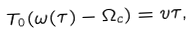Convert formula to latex. <formula><loc_0><loc_0><loc_500><loc_500>T _ { 0 } ( \omega ( \tau ) - \Omega _ { c } ) = v \tau ,</formula> 